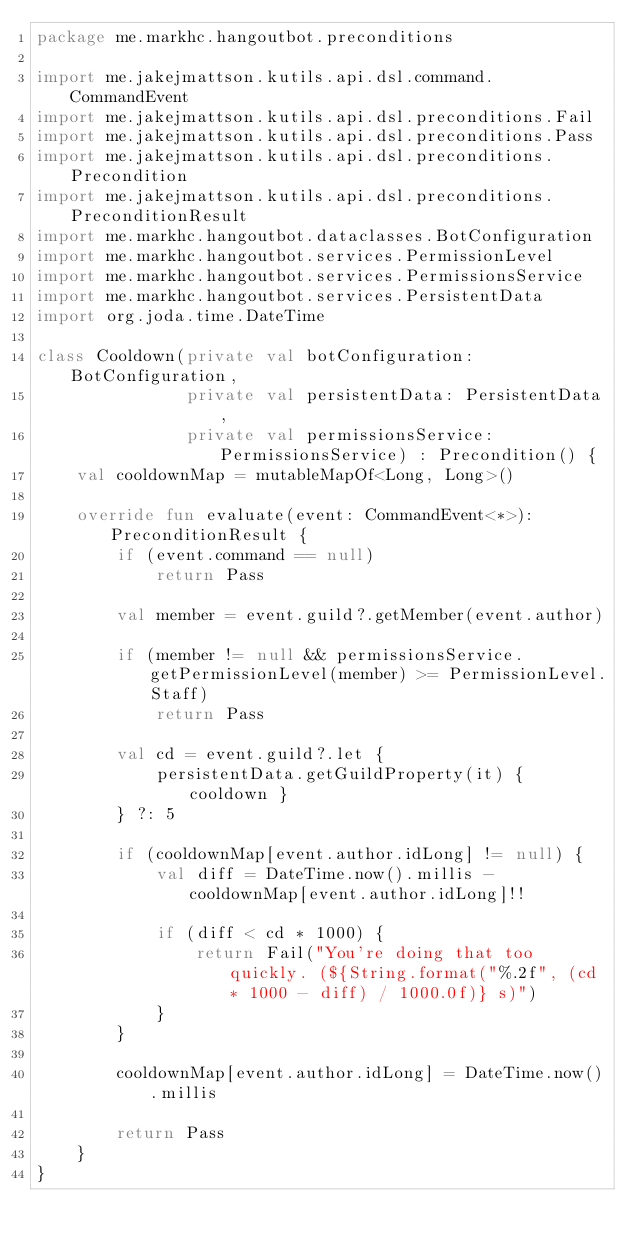Convert code to text. <code><loc_0><loc_0><loc_500><loc_500><_Kotlin_>package me.markhc.hangoutbot.preconditions

import me.jakejmattson.kutils.api.dsl.command.CommandEvent
import me.jakejmattson.kutils.api.dsl.preconditions.Fail
import me.jakejmattson.kutils.api.dsl.preconditions.Pass
import me.jakejmattson.kutils.api.dsl.preconditions.Precondition
import me.jakejmattson.kutils.api.dsl.preconditions.PreconditionResult
import me.markhc.hangoutbot.dataclasses.BotConfiguration
import me.markhc.hangoutbot.services.PermissionLevel
import me.markhc.hangoutbot.services.PermissionsService
import me.markhc.hangoutbot.services.PersistentData
import org.joda.time.DateTime

class Cooldown(private val botConfiguration: BotConfiguration,
               private val persistentData: PersistentData,
               private val permissionsService: PermissionsService) : Precondition() {
    val cooldownMap = mutableMapOf<Long, Long>()

    override fun evaluate(event: CommandEvent<*>): PreconditionResult {
        if (event.command == null)
            return Pass

        val member = event.guild?.getMember(event.author)

        if (member != null && permissionsService.getPermissionLevel(member) >= PermissionLevel.Staff)
            return Pass

        val cd = event.guild?.let {
            persistentData.getGuildProperty(it) { cooldown }
        } ?: 5

        if (cooldownMap[event.author.idLong] != null) {
            val diff = DateTime.now().millis - cooldownMap[event.author.idLong]!!

            if (diff < cd * 1000) {
                return Fail("You're doing that too quickly. (${String.format("%.2f", (cd * 1000 - diff) / 1000.0f)} s)")
            }
        }

        cooldownMap[event.author.idLong] = DateTime.now().millis

        return Pass
    }
}</code> 